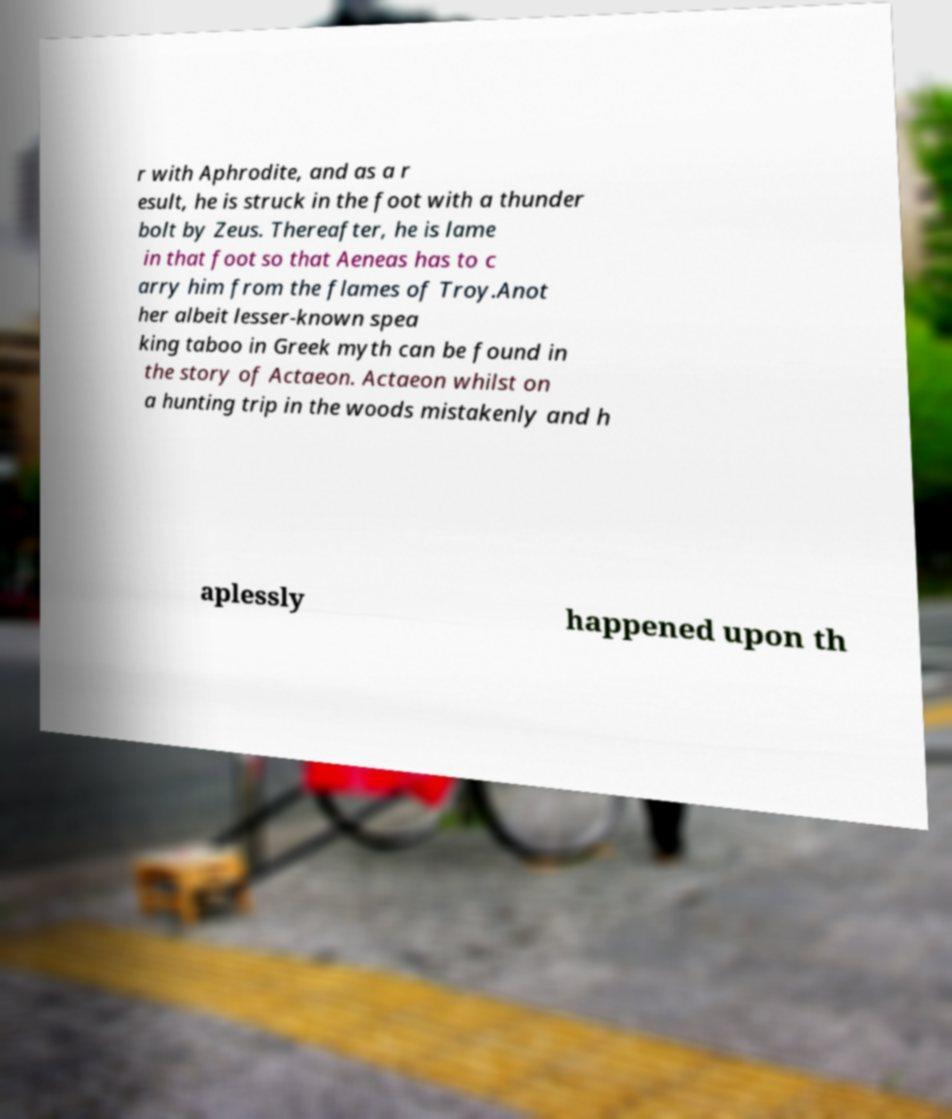Could you assist in decoding the text presented in this image and type it out clearly? r with Aphrodite, and as a r esult, he is struck in the foot with a thunder bolt by Zeus. Thereafter, he is lame in that foot so that Aeneas has to c arry him from the flames of Troy.Anot her albeit lesser-known spea king taboo in Greek myth can be found in the story of Actaeon. Actaeon whilst on a hunting trip in the woods mistakenly and h aplessly happened upon th 